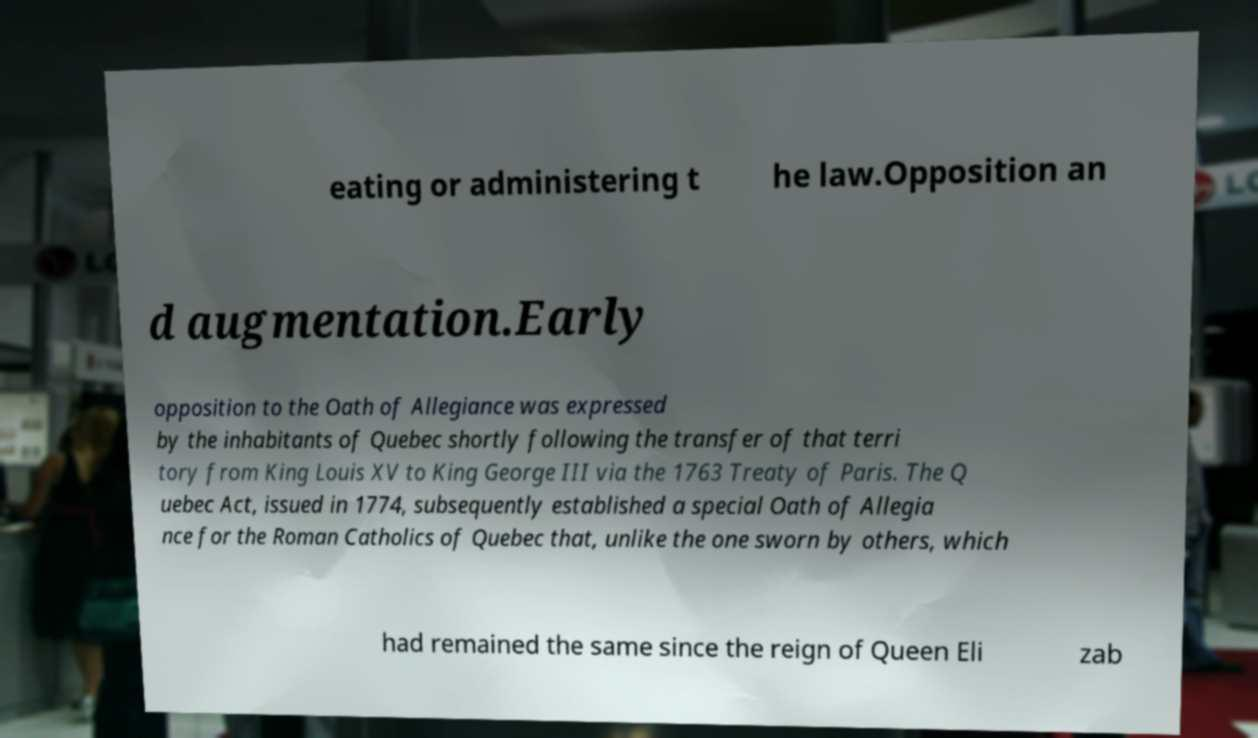Could you extract and type out the text from this image? eating or administering t he law.Opposition an d augmentation.Early opposition to the Oath of Allegiance was expressed by the inhabitants of Quebec shortly following the transfer of that terri tory from King Louis XV to King George III via the 1763 Treaty of Paris. The Q uebec Act, issued in 1774, subsequently established a special Oath of Allegia nce for the Roman Catholics of Quebec that, unlike the one sworn by others, which had remained the same since the reign of Queen Eli zab 